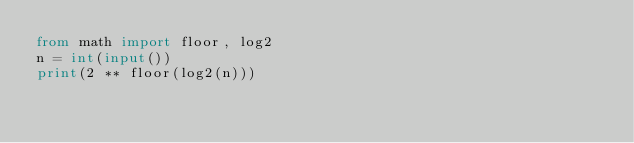<code> <loc_0><loc_0><loc_500><loc_500><_Python_>from math import floor, log2
n = int(input())
print(2 ** floor(log2(n)))</code> 